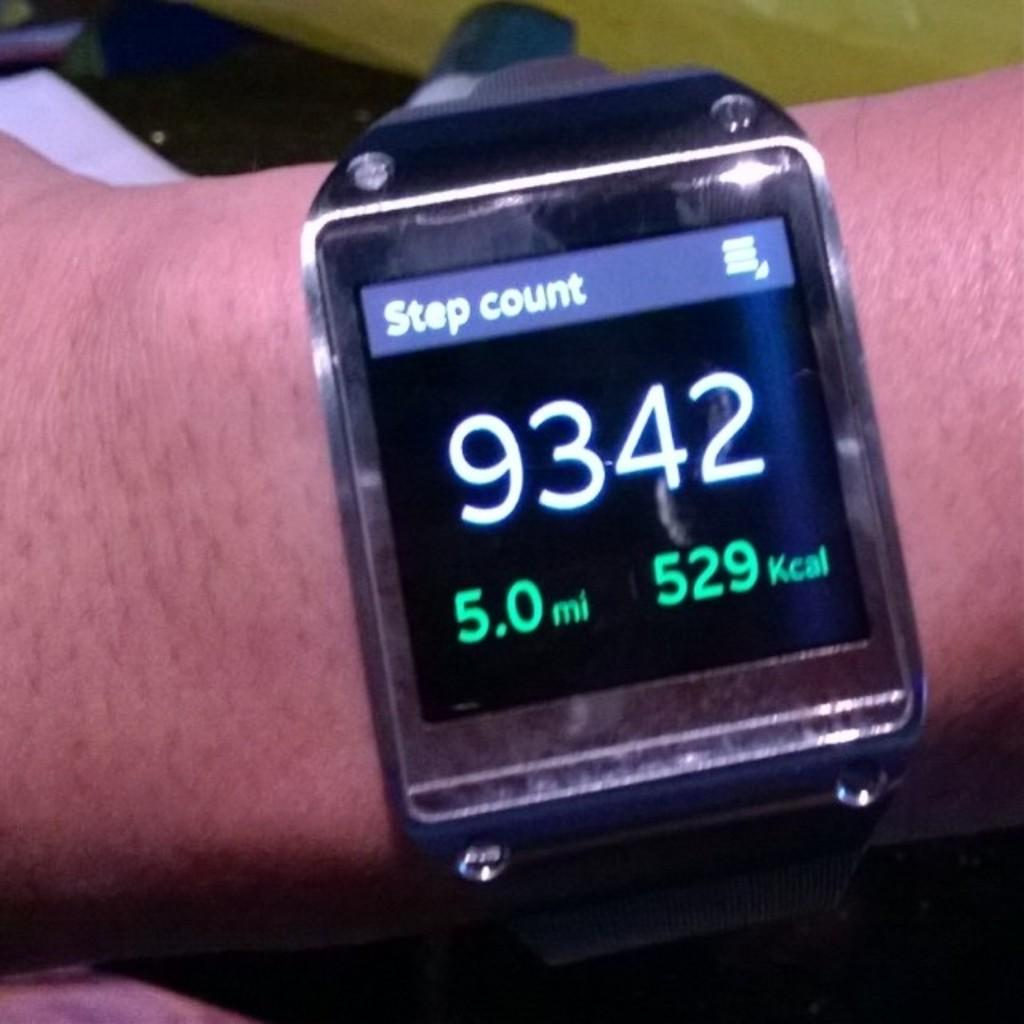<image>
Summarize the visual content of the image. A watch showing the step count and miles 